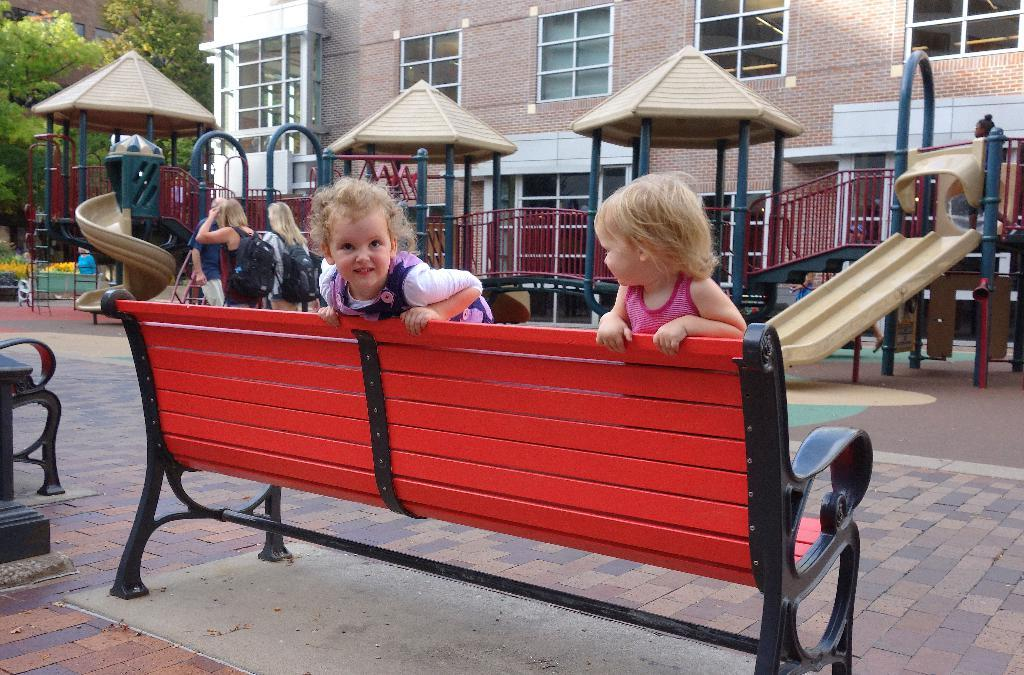What are the two persons in the image doing? The two persons are sitting on a bench in the center of the image. What can be seen in the background of the image? There is a building, a fence, trees, and a road in the background of the image. Are there any other people visible in the image? Yes, there are people walking on the road in the background of the image. Why is the banana crying in the image? There is no banana present in the image, and therefore it cannot be crying. 